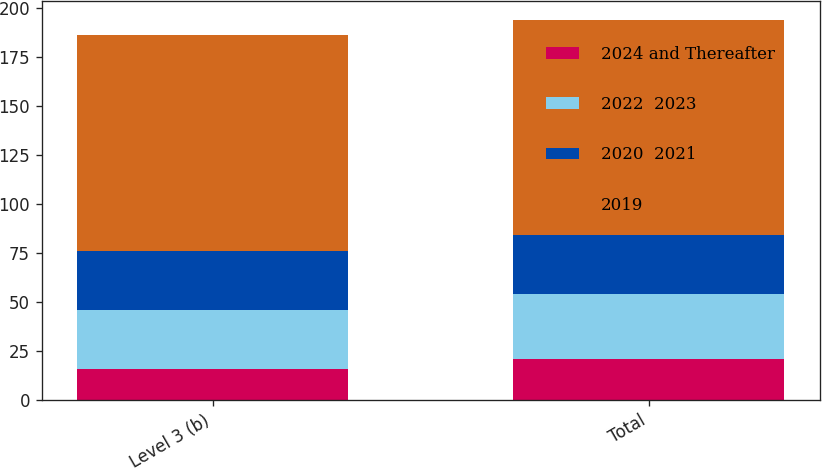<chart> <loc_0><loc_0><loc_500><loc_500><stacked_bar_chart><ecel><fcel>Level 3 (b)<fcel>Total<nl><fcel>2024 and Thereafter<fcel>16<fcel>21<nl><fcel>2022  2023<fcel>30<fcel>33<nl><fcel>2020  2021<fcel>30<fcel>30<nl><fcel>2019<fcel>110<fcel>110<nl></chart> 